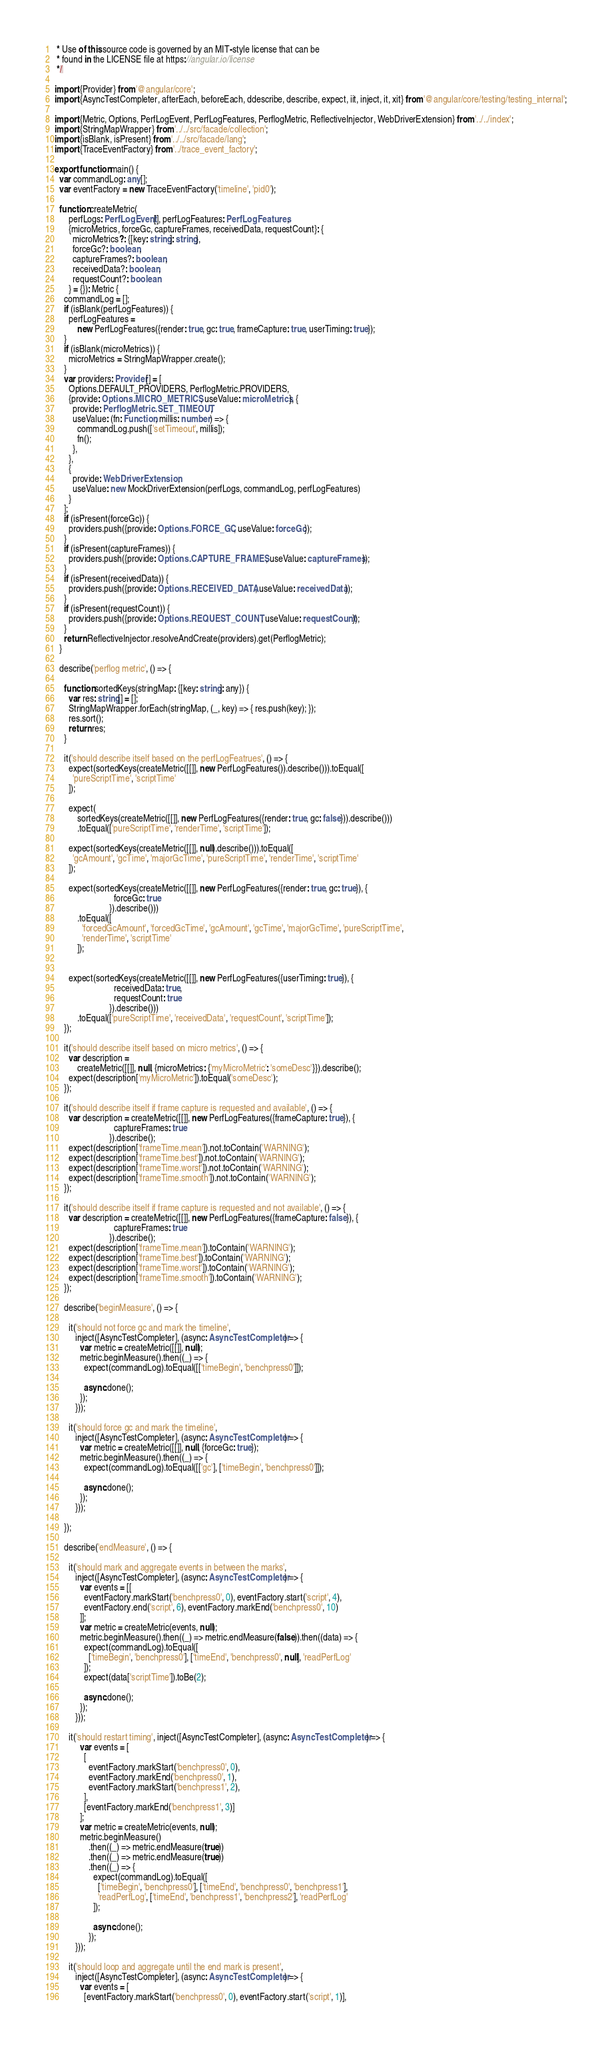Convert code to text. <code><loc_0><loc_0><loc_500><loc_500><_TypeScript_> * Use of this source code is governed by an MIT-style license that can be
 * found in the LICENSE file at https://angular.io/license
 */

import {Provider} from '@angular/core';
import {AsyncTestCompleter, afterEach, beforeEach, ddescribe, describe, expect, iit, inject, it, xit} from '@angular/core/testing/testing_internal';

import {Metric, Options, PerfLogEvent, PerfLogFeatures, PerflogMetric, ReflectiveInjector, WebDriverExtension} from '../../index';
import {StringMapWrapper} from '../../src/facade/collection';
import {isBlank, isPresent} from '../../src/facade/lang';
import {TraceEventFactory} from '../trace_event_factory';

export function main() {
  var commandLog: any[];
  var eventFactory = new TraceEventFactory('timeline', 'pid0');

  function createMetric(
      perfLogs: PerfLogEvent[], perfLogFeatures: PerfLogFeatures,
      {microMetrics, forceGc, captureFrames, receivedData, requestCount}: {
        microMetrics?: {[key: string]: string},
        forceGc?: boolean,
        captureFrames?: boolean,
        receivedData?: boolean,
        requestCount?: boolean
      } = {}): Metric {
    commandLog = [];
    if (isBlank(perfLogFeatures)) {
      perfLogFeatures =
          new PerfLogFeatures({render: true, gc: true, frameCapture: true, userTiming: true});
    }
    if (isBlank(microMetrics)) {
      microMetrics = StringMapWrapper.create();
    }
    var providers: Provider[] = [
      Options.DEFAULT_PROVIDERS, PerflogMetric.PROVIDERS,
      {provide: Options.MICRO_METRICS, useValue: microMetrics}, {
        provide: PerflogMetric.SET_TIMEOUT,
        useValue: (fn: Function, millis: number) => {
          commandLog.push(['setTimeout', millis]);
          fn();
        },
      },
      {
        provide: WebDriverExtension,
        useValue: new MockDriverExtension(perfLogs, commandLog, perfLogFeatures)
      }
    ];
    if (isPresent(forceGc)) {
      providers.push({provide: Options.FORCE_GC, useValue: forceGc});
    }
    if (isPresent(captureFrames)) {
      providers.push({provide: Options.CAPTURE_FRAMES, useValue: captureFrames});
    }
    if (isPresent(receivedData)) {
      providers.push({provide: Options.RECEIVED_DATA, useValue: receivedData});
    }
    if (isPresent(requestCount)) {
      providers.push({provide: Options.REQUEST_COUNT, useValue: requestCount});
    }
    return ReflectiveInjector.resolveAndCreate(providers).get(PerflogMetric);
  }

  describe('perflog metric', () => {

    function sortedKeys(stringMap: {[key: string]: any}) {
      var res: string[] = [];
      StringMapWrapper.forEach(stringMap, (_, key) => { res.push(key); });
      res.sort();
      return res;
    }

    it('should describe itself based on the perfLogFeatrues', () => {
      expect(sortedKeys(createMetric([[]], new PerfLogFeatures()).describe())).toEqual([
        'pureScriptTime', 'scriptTime'
      ]);

      expect(
          sortedKeys(createMetric([[]], new PerfLogFeatures({render: true, gc: false})).describe()))
          .toEqual(['pureScriptTime', 'renderTime', 'scriptTime']);

      expect(sortedKeys(createMetric([[]], null).describe())).toEqual([
        'gcAmount', 'gcTime', 'majorGcTime', 'pureScriptTime', 'renderTime', 'scriptTime'
      ]);

      expect(sortedKeys(createMetric([[]], new PerfLogFeatures({render: true, gc: true}), {
                          forceGc: true
                        }).describe()))
          .toEqual([
            'forcedGcAmount', 'forcedGcTime', 'gcAmount', 'gcTime', 'majorGcTime', 'pureScriptTime',
            'renderTime', 'scriptTime'
          ]);


      expect(sortedKeys(createMetric([[]], new PerfLogFeatures({userTiming: true}), {
                          receivedData: true,
                          requestCount: true
                        }).describe()))
          .toEqual(['pureScriptTime', 'receivedData', 'requestCount', 'scriptTime']);
    });

    it('should describe itself based on micro metrics', () => {
      var description =
          createMetric([[]], null, {microMetrics: {'myMicroMetric': 'someDesc'}}).describe();
      expect(description['myMicroMetric']).toEqual('someDesc');
    });

    it('should describe itself if frame capture is requested and available', () => {
      var description = createMetric([[]], new PerfLogFeatures({frameCapture: true}), {
                          captureFrames: true
                        }).describe();
      expect(description['frameTime.mean']).not.toContain('WARNING');
      expect(description['frameTime.best']).not.toContain('WARNING');
      expect(description['frameTime.worst']).not.toContain('WARNING');
      expect(description['frameTime.smooth']).not.toContain('WARNING');
    });

    it('should describe itself if frame capture is requested and not available', () => {
      var description = createMetric([[]], new PerfLogFeatures({frameCapture: false}), {
                          captureFrames: true
                        }).describe();
      expect(description['frameTime.mean']).toContain('WARNING');
      expect(description['frameTime.best']).toContain('WARNING');
      expect(description['frameTime.worst']).toContain('WARNING');
      expect(description['frameTime.smooth']).toContain('WARNING');
    });

    describe('beginMeasure', () => {

      it('should not force gc and mark the timeline',
         inject([AsyncTestCompleter], (async: AsyncTestCompleter) => {
           var metric = createMetric([[]], null);
           metric.beginMeasure().then((_) => {
             expect(commandLog).toEqual([['timeBegin', 'benchpress0']]);

             async.done();
           });
         }));

      it('should force gc and mark the timeline',
         inject([AsyncTestCompleter], (async: AsyncTestCompleter) => {
           var metric = createMetric([[]], null, {forceGc: true});
           metric.beginMeasure().then((_) => {
             expect(commandLog).toEqual([['gc'], ['timeBegin', 'benchpress0']]);

             async.done();
           });
         }));

    });

    describe('endMeasure', () => {

      it('should mark and aggregate events in between the marks',
         inject([AsyncTestCompleter], (async: AsyncTestCompleter) => {
           var events = [[
             eventFactory.markStart('benchpress0', 0), eventFactory.start('script', 4),
             eventFactory.end('script', 6), eventFactory.markEnd('benchpress0', 10)
           ]];
           var metric = createMetric(events, null);
           metric.beginMeasure().then((_) => metric.endMeasure(false)).then((data) => {
             expect(commandLog).toEqual([
               ['timeBegin', 'benchpress0'], ['timeEnd', 'benchpress0', null], 'readPerfLog'
             ]);
             expect(data['scriptTime']).toBe(2);

             async.done();
           });
         }));

      it('should restart timing', inject([AsyncTestCompleter], (async: AsyncTestCompleter) => {
           var events = [
             [
               eventFactory.markStart('benchpress0', 0),
               eventFactory.markEnd('benchpress0', 1),
               eventFactory.markStart('benchpress1', 2),
             ],
             [eventFactory.markEnd('benchpress1', 3)]
           ];
           var metric = createMetric(events, null);
           metric.beginMeasure()
               .then((_) => metric.endMeasure(true))
               .then((_) => metric.endMeasure(true))
               .then((_) => {
                 expect(commandLog).toEqual([
                   ['timeBegin', 'benchpress0'], ['timeEnd', 'benchpress0', 'benchpress1'],
                   'readPerfLog', ['timeEnd', 'benchpress1', 'benchpress2'], 'readPerfLog'
                 ]);

                 async.done();
               });
         }));

      it('should loop and aggregate until the end mark is present',
         inject([AsyncTestCompleter], (async: AsyncTestCompleter) => {
           var events = [
             [eventFactory.markStart('benchpress0', 0), eventFactory.start('script', 1)],</code> 